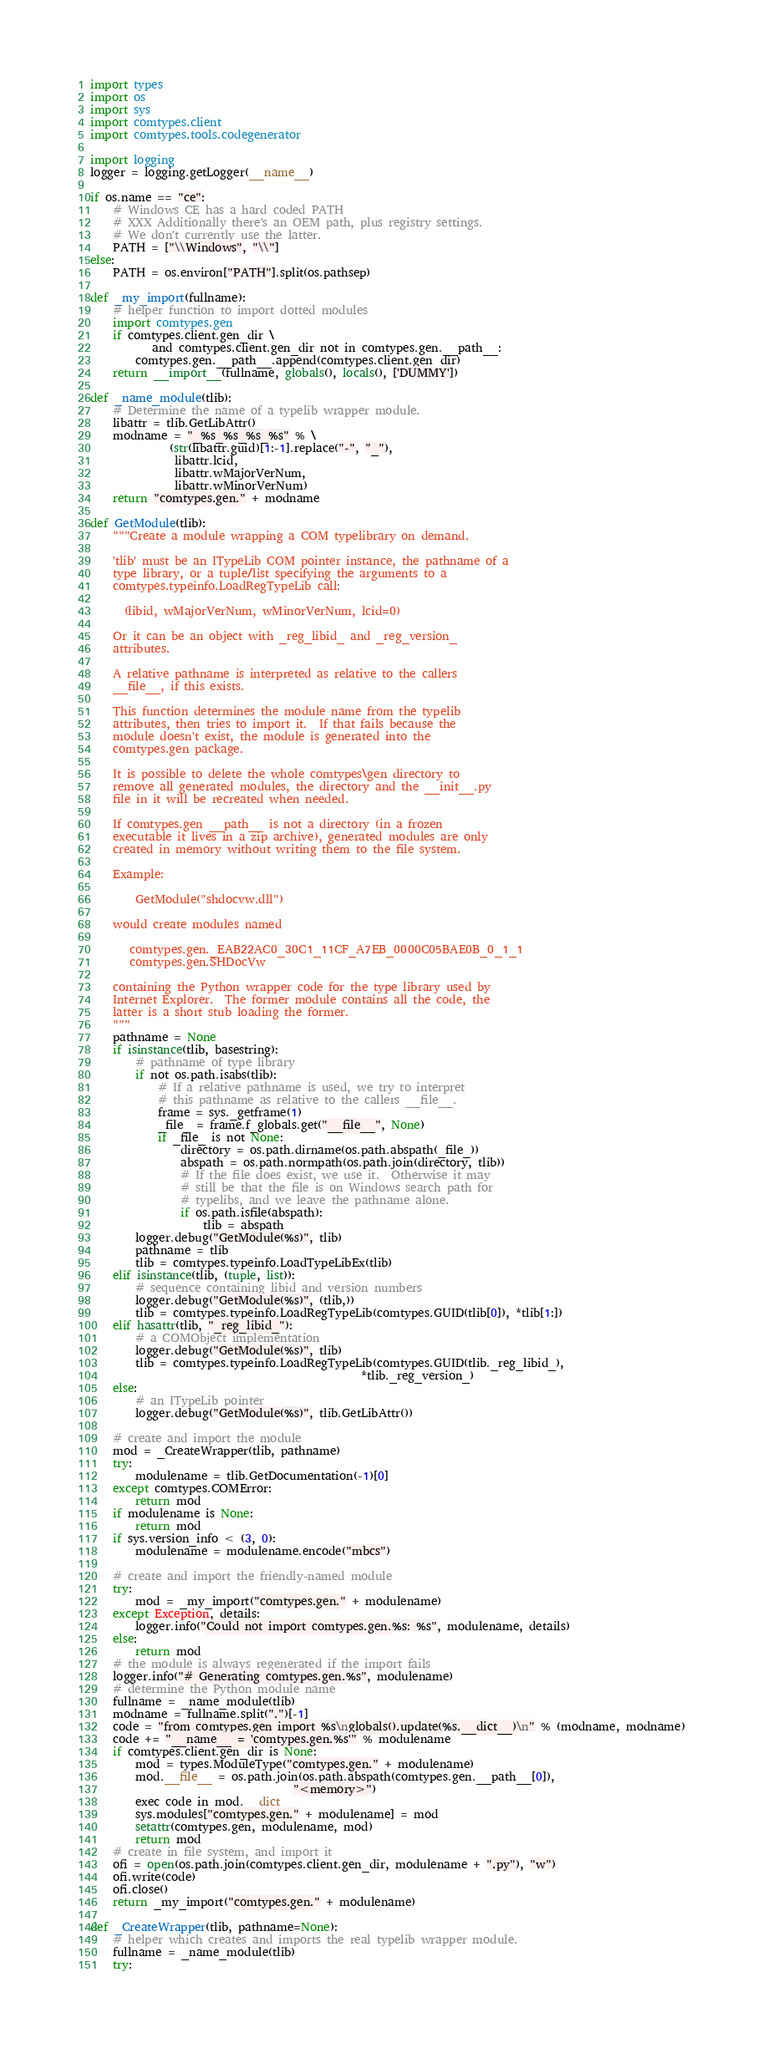<code> <loc_0><loc_0><loc_500><loc_500><_Python_>import types
import os
import sys
import comtypes.client
import comtypes.tools.codegenerator

import logging
logger = logging.getLogger(__name__)

if os.name == "ce":
    # Windows CE has a hard coded PATH
    # XXX Additionally there's an OEM path, plus registry settings.
    # We don't currently use the latter.
    PATH = ["\\Windows", "\\"]
else:
    PATH = os.environ["PATH"].split(os.pathsep)

def _my_import(fullname):
    # helper function to import dotted modules
    import comtypes.gen
    if comtypes.client.gen_dir \
           and comtypes.client.gen_dir not in comtypes.gen.__path__:
        comtypes.gen.__path__.append(comtypes.client.gen_dir)
    return __import__(fullname, globals(), locals(), ['DUMMY'])

def _name_module(tlib):
    # Determine the name of a typelib wrapper module.
    libattr = tlib.GetLibAttr()
    modname = "_%s_%s_%s_%s" % \
              (str(libattr.guid)[1:-1].replace("-", "_"),
               libattr.lcid,
               libattr.wMajorVerNum,
               libattr.wMinorVerNum)
    return "comtypes.gen." + modname

def GetModule(tlib):
    """Create a module wrapping a COM typelibrary on demand.

    'tlib' must be an ITypeLib COM pointer instance, the pathname of a
    type library, or a tuple/list specifying the arguments to a
    comtypes.typeinfo.LoadRegTypeLib call:

      (libid, wMajorVerNum, wMinorVerNum, lcid=0)

    Or it can be an object with _reg_libid_ and _reg_version_
    attributes.

    A relative pathname is interpreted as relative to the callers
    __file__, if this exists.

    This function determines the module name from the typelib
    attributes, then tries to import it.  If that fails because the
    module doesn't exist, the module is generated into the
    comtypes.gen package.

    It is possible to delete the whole comtypes\gen directory to
    remove all generated modules, the directory and the __init__.py
    file in it will be recreated when needed.

    If comtypes.gen __path__ is not a directory (in a frozen
    executable it lives in a zip archive), generated modules are only
    created in memory without writing them to the file system.

    Example:

        GetModule("shdocvw.dll")

    would create modules named

       comtypes.gen._EAB22AC0_30C1_11CF_A7EB_0000C05BAE0B_0_1_1
       comtypes.gen.SHDocVw

    containing the Python wrapper code for the type library used by
    Internet Explorer.  The former module contains all the code, the
    latter is a short stub loading the former.
    """
    pathname = None
    if isinstance(tlib, basestring):
        # pathname of type library
        if not os.path.isabs(tlib):
            # If a relative pathname is used, we try to interpret
            # this pathname as relative to the callers __file__.
            frame = sys._getframe(1)
            _file_ = frame.f_globals.get("__file__", None)
            if _file_ is not None:
                directory = os.path.dirname(os.path.abspath(_file_))
                abspath = os.path.normpath(os.path.join(directory, tlib))
                # If the file does exist, we use it.  Otherwise it may
                # still be that the file is on Windows search path for
                # typelibs, and we leave the pathname alone.
                if os.path.isfile(abspath):
                    tlib = abspath
        logger.debug("GetModule(%s)", tlib)
        pathname = tlib
        tlib = comtypes.typeinfo.LoadTypeLibEx(tlib)
    elif isinstance(tlib, (tuple, list)):
        # sequence containing libid and version numbers
        logger.debug("GetModule(%s)", (tlib,))
        tlib = comtypes.typeinfo.LoadRegTypeLib(comtypes.GUID(tlib[0]), *tlib[1:])
    elif hasattr(tlib, "_reg_libid_"):
        # a COMObject implementation
        logger.debug("GetModule(%s)", tlib)
        tlib = comtypes.typeinfo.LoadRegTypeLib(comtypes.GUID(tlib._reg_libid_),
                                                *tlib._reg_version_)
    else:
        # an ITypeLib pointer
        logger.debug("GetModule(%s)", tlib.GetLibAttr())

    # create and import the module
    mod = _CreateWrapper(tlib, pathname)
    try:
        modulename = tlib.GetDocumentation(-1)[0]
    except comtypes.COMError:
        return mod
    if modulename is None:
        return mod
    if sys.version_info < (3, 0):
        modulename = modulename.encode("mbcs")

    # create and import the friendly-named module
    try:
        mod = _my_import("comtypes.gen." + modulename)
    except Exception, details:
        logger.info("Could not import comtypes.gen.%s: %s", modulename, details)
    else:
        return mod
    # the module is always regenerated if the import fails
    logger.info("# Generating comtypes.gen.%s", modulename)
    # determine the Python module name
    fullname = _name_module(tlib)
    modname = fullname.split(".")[-1]
    code = "from comtypes.gen import %s\nglobals().update(%s.__dict__)\n" % (modname, modname)
    code += "__name__ = 'comtypes.gen.%s'" % modulename
    if comtypes.client.gen_dir is None:
        mod = types.ModuleType("comtypes.gen." + modulename)
        mod.__file__ = os.path.join(os.path.abspath(comtypes.gen.__path__[0]),
                                    "<memory>")
        exec code in mod.__dict__
        sys.modules["comtypes.gen." + modulename] = mod
        setattr(comtypes.gen, modulename, mod)
        return mod
    # create in file system, and import it
    ofi = open(os.path.join(comtypes.client.gen_dir, modulename + ".py"), "w")
    ofi.write(code)
    ofi.close()
    return _my_import("comtypes.gen." + modulename)

def _CreateWrapper(tlib, pathname=None):
    # helper which creates and imports the real typelib wrapper module.
    fullname = _name_module(tlib)
    try:</code> 